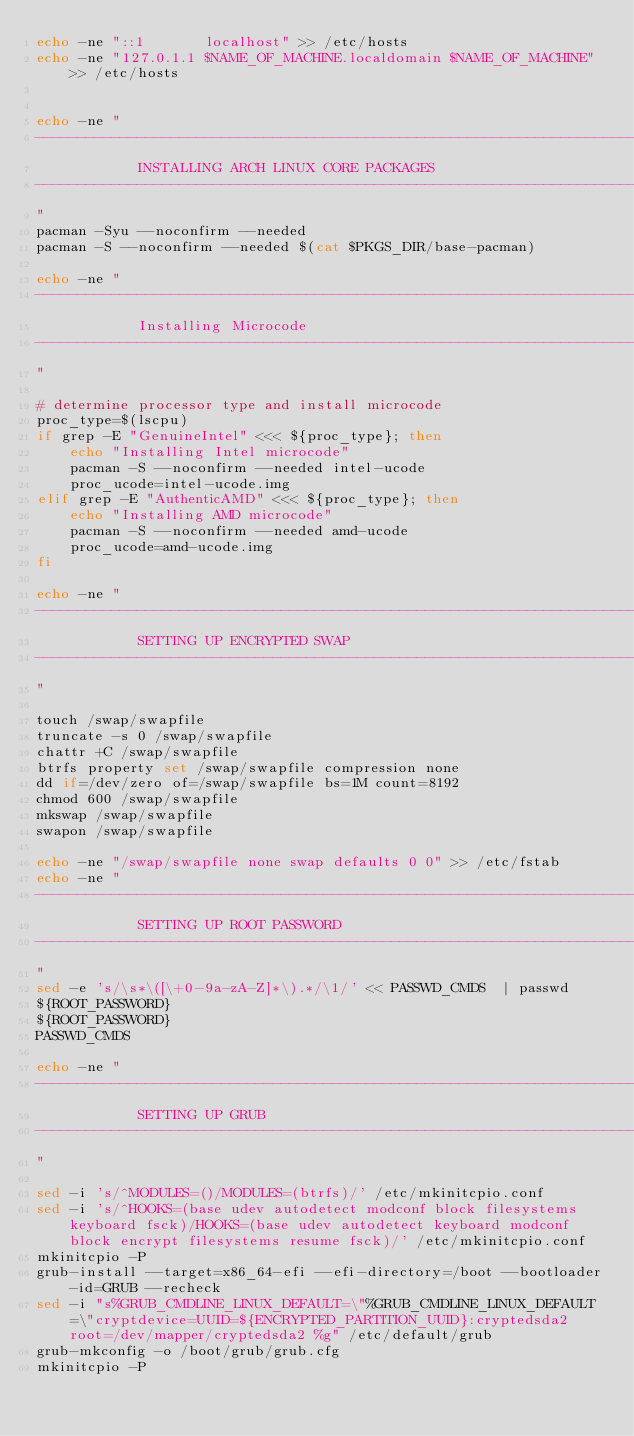Convert code to text. <code><loc_0><loc_0><loc_500><loc_500><_Bash_>echo -ne "::1       localhost" >> /etc/hosts
echo -ne "127.0.1.1 $NAME_OF_MACHINE.localdomain $NAME_OF_MACHINE" >> /etc/hosts


echo -ne "
-------------------------------------------------------------------------
            INSTALLING ARCH LINUX CORE PACKAGES
-------------------------------------------------------------------------
"
pacman -Syu --noconfirm --needed
pacman -S --noconfirm --needed $(cat $PKGS_DIR/base-pacman)

echo -ne "
-------------------------------------------------------------------------
            Installing Microcode
-------------------------------------------------------------------------
"

# determine processor type and install microcode
proc_type=$(lscpu)
if grep -E "GenuineIntel" <<< ${proc_type}; then
    echo "Installing Intel microcode"
    pacman -S --noconfirm --needed intel-ucode
    proc_ucode=intel-ucode.img
elif grep -E "AuthenticAMD" <<< ${proc_type}; then
    echo "Installing AMD microcode"
    pacman -S --noconfirm --needed amd-ucode
    proc_ucode=amd-ucode.img
fi

echo -ne "
-------------------------------------------------------------------------
            SETTING UP ENCRYPTED SWAP
-------------------------------------------------------------------------
"

touch /swap/swapfile
truncate -s 0 /swap/swapfile
chattr +C /swap/swapfile
btrfs property set /swap/swapfile compression none
dd if=/dev/zero of=/swap/swapfile bs=1M count=8192
chmod 600 /swap/swapfile
mkswap /swap/swapfile
swapon /swap/swapfile

echo -ne "/swap/swapfile none swap defaults 0 0" >> /etc/fstab
echo -ne "
-------------------------------------------------------------------------
            SETTING UP ROOT PASSWORD
-------------------------------------------------------------------------
"
sed -e 's/\s*\([\+0-9a-zA-Z]*\).*/\1/' << PASSWD_CMDS  | passwd
${ROOT_PASSWORD}
${ROOT_PASSWORD}
PASSWD_CMDS

echo -ne "
-------------------------------------------------------------------------
            SETTING UP GRUB
-------------------------------------------------------------------------
"

sed -i 's/^MODULES=()/MODULES=(btrfs)/' /etc/mkinitcpio.conf
sed -i 's/^HOOKS=(base udev autodetect modconf block filesystems keyboard fsck)/HOOKS=(base udev autodetect keyboard modconf block encrypt filesystems resume fsck)/' /etc/mkinitcpio.conf
mkinitcpio -P
grub-install --target=x86_64-efi --efi-directory=/boot --bootloader-id=GRUB --recheck
sed -i "s%GRUB_CMDLINE_LINUX_DEFAULT=\"%GRUB_CMDLINE_LINUX_DEFAULT=\"cryptdevice=UUID=${ENCRYPTED_PARTITION_UUID}:cryptedsda2 root=/dev/mapper/cryptedsda2 %g" /etc/default/grub
grub-mkconfig -o /boot/grub/grub.cfg
mkinitcpio -P 
</code> 